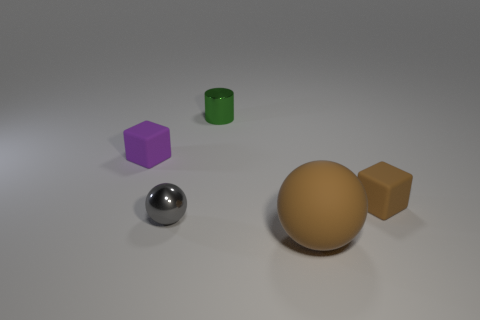Add 4 large gray metal cylinders. How many objects exist? 9 Subtract all balls. How many objects are left? 3 Subtract 0 blue balls. How many objects are left? 5 Subtract all red metallic balls. Subtract all tiny gray metallic objects. How many objects are left? 4 Add 4 small purple rubber things. How many small purple rubber things are left? 5 Add 5 tiny metallic cylinders. How many tiny metallic cylinders exist? 6 